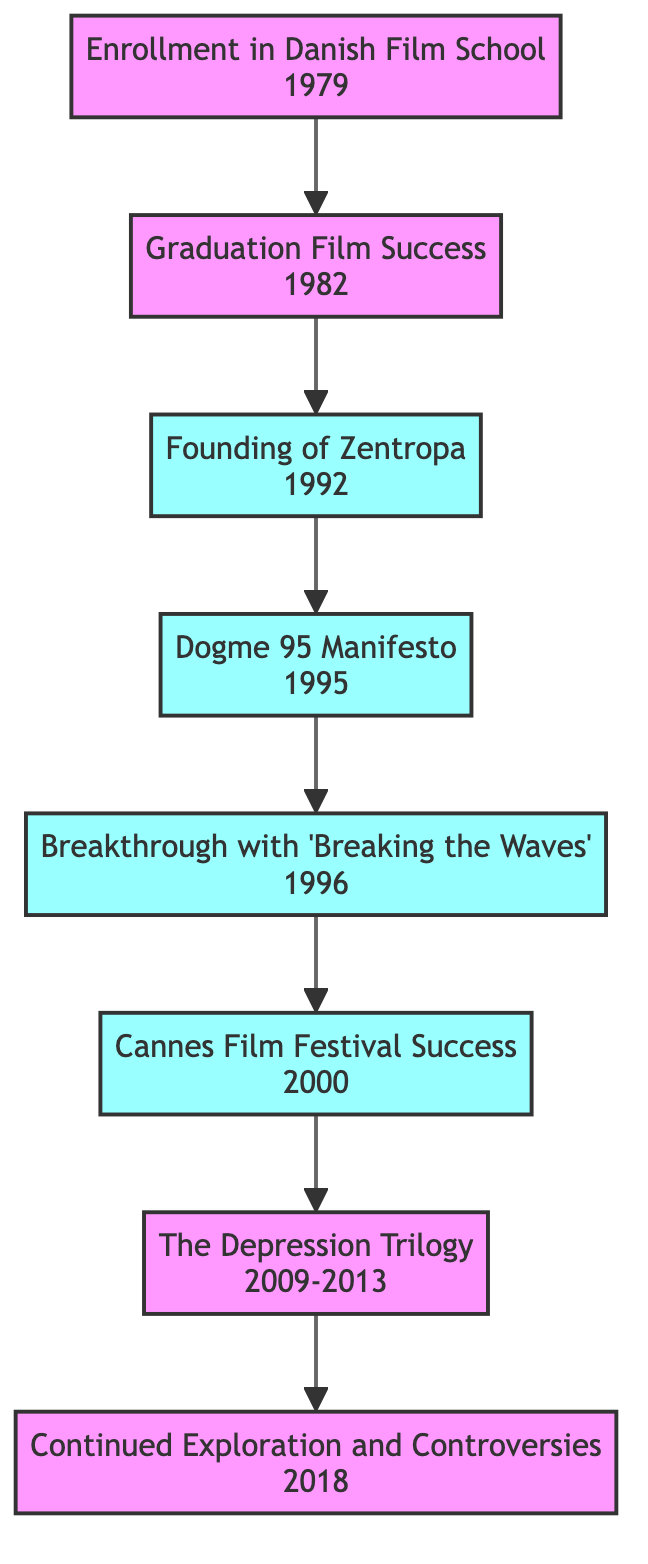What is the first step in Lars Von Trier's career path? The first step is "Enrollment in Danish Film School" which is represented as the starting node in the diagram.
Answer: Enrollment in Danish Film School What is the significance of the year 1995 in the diagram? In 1995, Lars Von Trier co-founded the Dogme 95 movement, which is a crucial milestone in his career.
Answer: Dogme 95 Manifesto How many milestones are present in the diagram? The milestones represented in the diagram include founding Zentropa, the Dogme 95 Manifesto, the breakthrough with 'Breaking the Waves', and Cannes Film Festival success, totaling four significant milestones.
Answer: 4 What is the relationship between "Graduation Film Success" and "Founding of Zentropa"? "Graduation Film Success" leads to the next step, "Founding of Zentropa," indicating that graduation success contributed to the establishment of his production company.
Answer: Leads to What key event occurs after the "Cannes Film Festival Success"? The next step following the Cannes Film Festival Success is "The Depression Trilogy," showing the progression of his career.
Answer: The Depression Trilogy What were the years covered in "The Depression Trilogy"? The period for "The Depression Trilogy" spans from 2009 to 2013, as indicated in the diagram.
Answer: 2009-2013 Which step solidified Lars Von Trier's status on the international stage? The step that solidified his international status is "Cannes Film Festival Success," which won the Palme d'Or for 'Dancer in the Dark.'
Answer: Cannes Film Festival Success What step did Lars Von Trier take immediately after "Breakthrough with 'Breaking the Waves'"? After the breakthrough film, the immediate next step is "Cannes Film Festival Success," indicating a continued ascent in his career.
Answer: Cannes Film Festival Success 